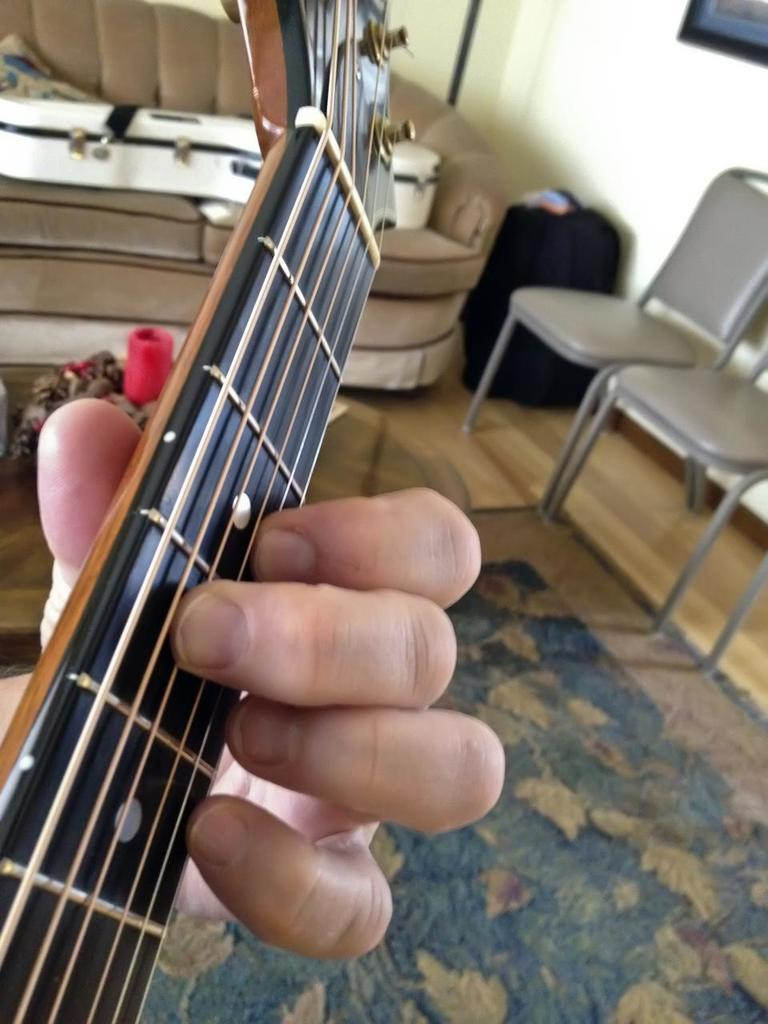What is the person in the image doing? There is a person playing guitar in the image. What can be seen in the background of the image? There are chairs and a sofa in the background of the image. What is the main architectural feature visible in the image? There is a wall visible in the image. How many senses can be seen in the image? There are no senses visible in the image, as senses are not physical objects that can be seen. 